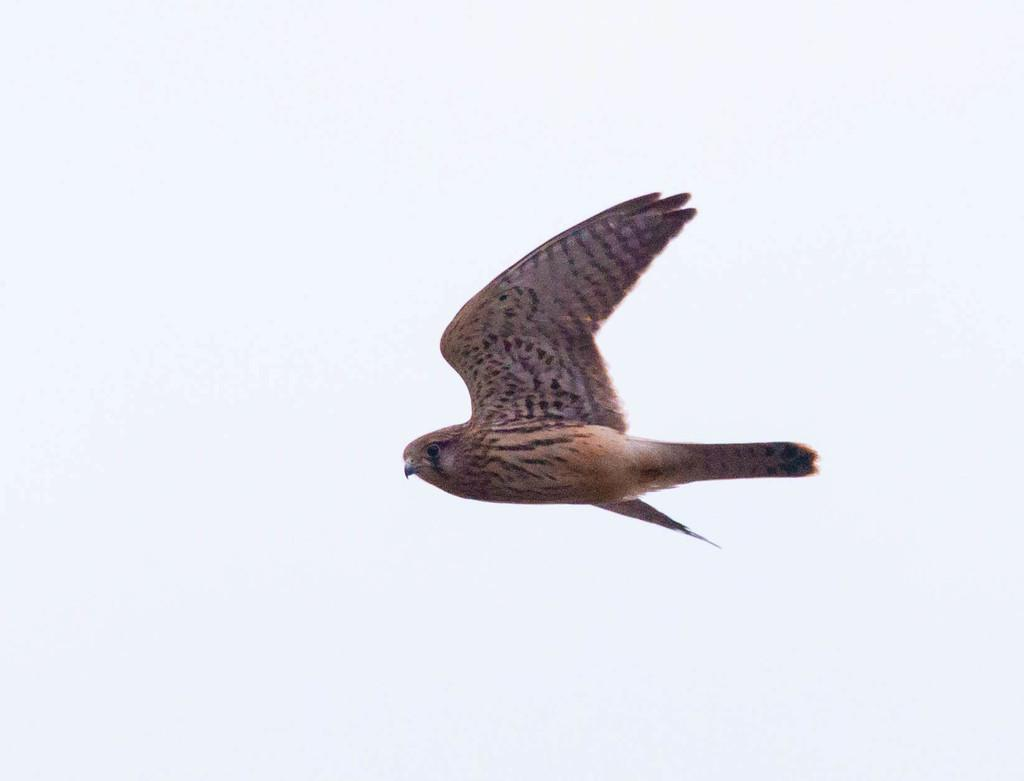What type of animal can be seen in the image? There is a bird in the image. What is the bird doing in the image? The bird is flying in the air. What type of attention does the bird's brother receive in the image? There is no mention of a brother or any attention in the image; it only features a bird flying in the air. 